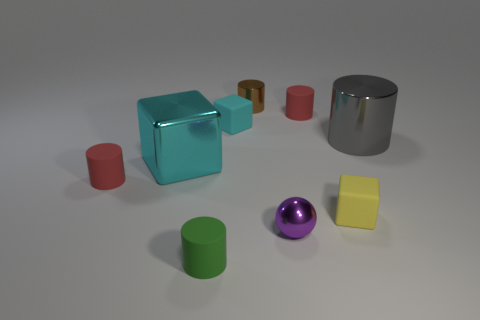Are there any cyan metallic things of the same shape as the small yellow thing?
Provide a short and direct response. Yes. Is the shape of the small yellow object that is behind the metallic ball the same as  the cyan shiny object?
Give a very brief answer. Yes. How many objects are both to the right of the yellow block and on the left side of the gray metallic cylinder?
Ensure brevity in your answer.  0. The tiny red matte thing that is to the right of the tiny green rubber object has what shape?
Offer a very short reply. Cylinder. What number of large cyan cylinders have the same material as the big cyan block?
Make the answer very short. 0. There is a large cyan shiny thing; does it have the same shape as the small cyan object that is behind the gray thing?
Offer a very short reply. Yes. There is a tiny red rubber object that is on the left side of the red matte thing that is to the right of the brown cylinder; are there any purple metal balls that are behind it?
Provide a short and direct response. No. There is a matte cylinder that is in front of the small yellow rubber thing; how big is it?
Your response must be concise. Small. What is the material of the thing that is the same size as the gray shiny cylinder?
Provide a short and direct response. Metal. Does the yellow matte object have the same shape as the large cyan metallic object?
Your answer should be very brief. Yes. 